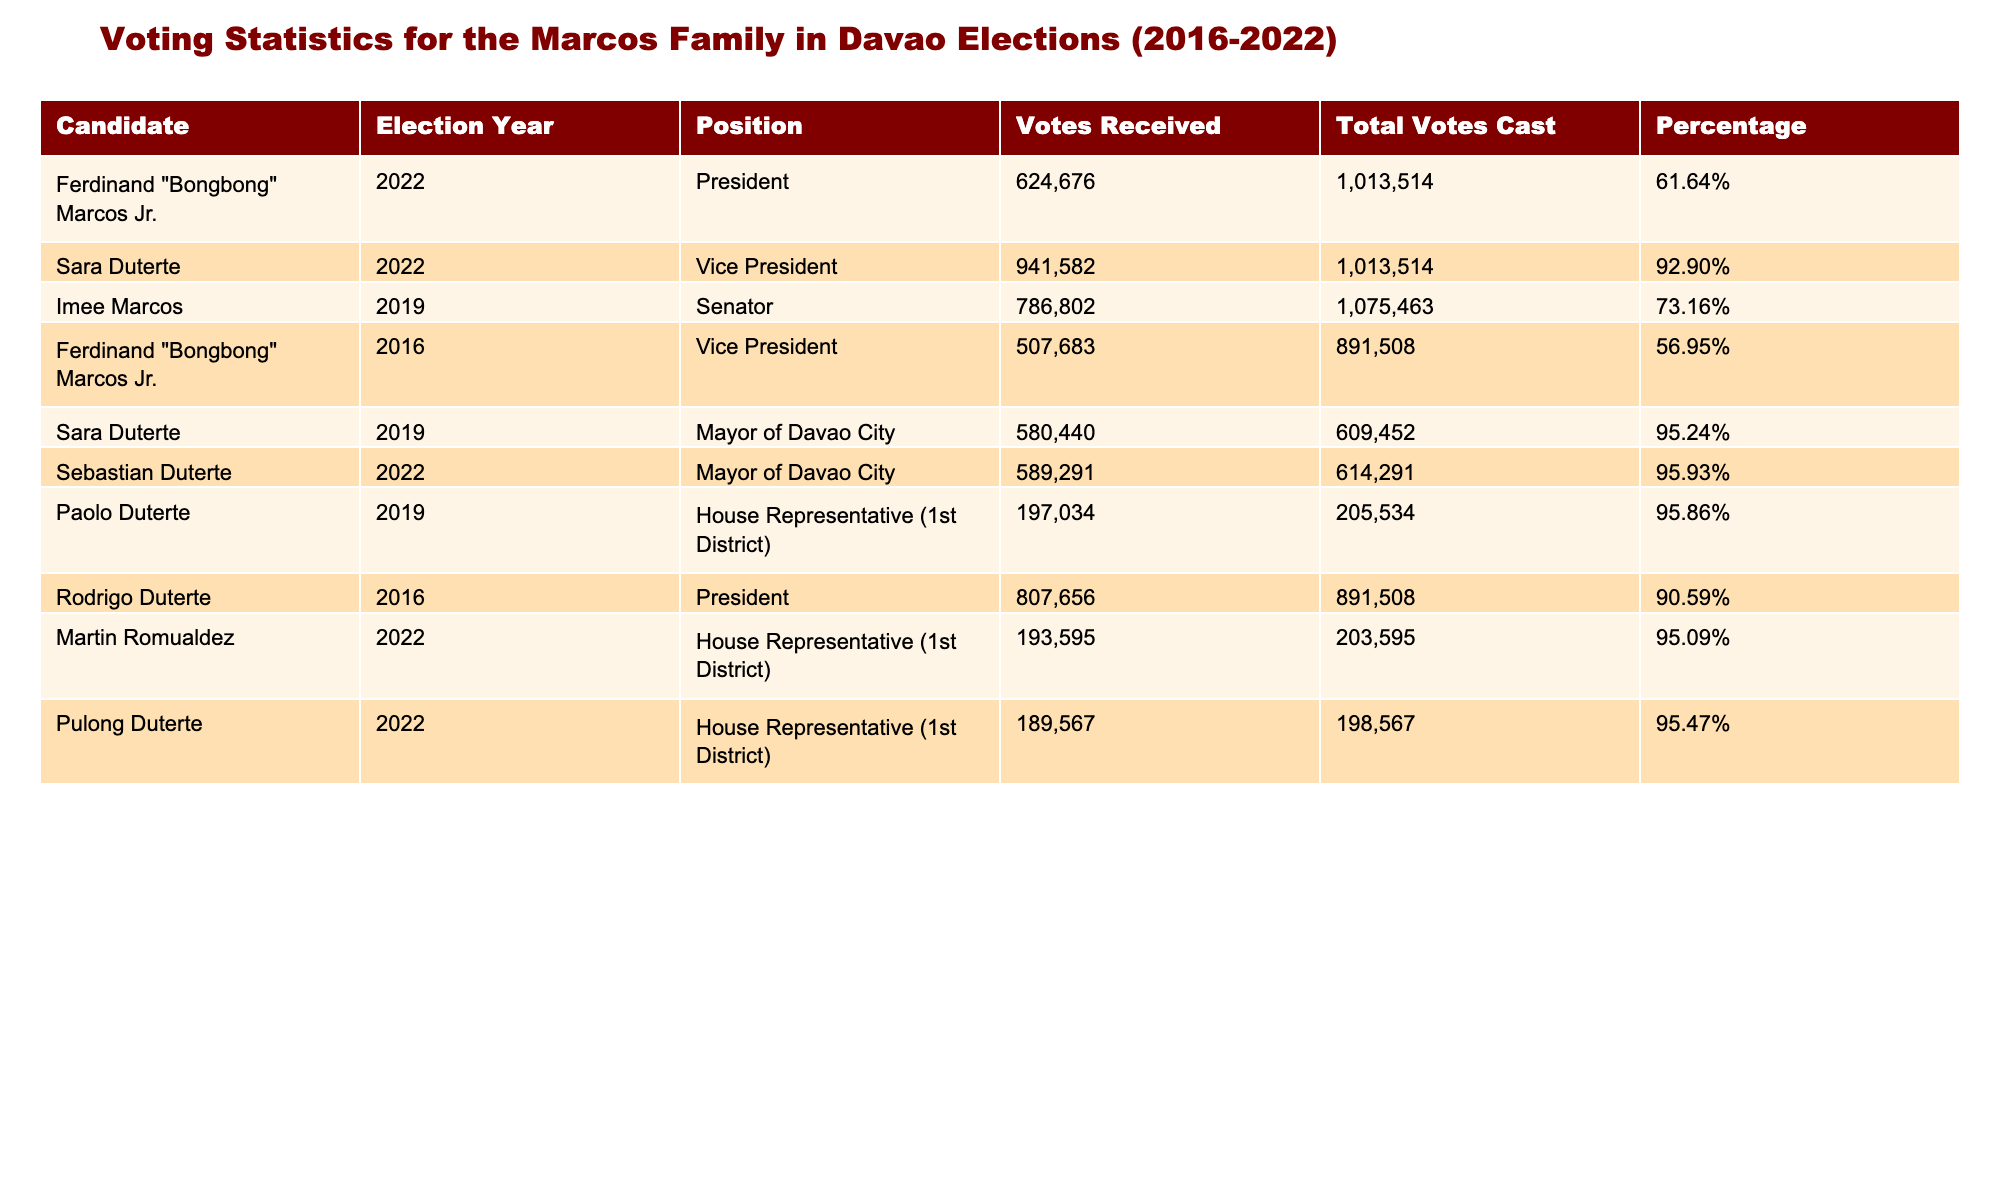What was the percentage of votes received by Ferdinand "Bongbong" Marcos Jr. in the 2022 presidential election? In the table, the percentage for Ferdinand "Bongbong" Marcos Jr. in the 2022 election is listed as 61.64%.
Answer: 61.64% Who received the most votes in the 2022 vice presidential election? The table shows that Sara Duterte received the most votes as Vice President in 2022 with 941,582 votes.
Answer: Sara Duterte What was the total number of votes cast in the 2019 senatorial election? According to the table, there were a total of 1,075,463 votes cast in the 2019 senatorial election.
Answer: 1,075,463 How much higher was the percentage of votes received by Sara Duterte in 2022 compared to Ferdinand "Bongbong" Marcos Jr. in 2016? Sara Duterte received 92.90% in 2022, while Ferdinand "Bongbong" Marcos Jr. received 56.95% in 2016. The difference is 92.90% - 56.95% = 35.95%.
Answer: 35.95% Did Imee Marcos receive more votes than Ferdinand "Bongbong" Marcos Jr. in the 2016 election? Imee Marcos received 786,802 votes in 2019 while Ferdinand "Bongbong" Marcos Jr. received 507,683 votes in 2016. Thus, Imee Marcos received more votes.
Answer: Yes What was the combined total of votes received by the Marcos family in the 2022 elections for President and Vice President? In 2022, Ferdinand "Bongbong" Marcos Jr. received 624,676 votes for President and Sara Duterte received 941,582 votes for Vice President. The total is 624,676 + 941,582 = 1,566,258 votes.
Answer: 1,566,258 Which candidate had the lowest percentage of votes in the elections listed? The table shows that Ferdinand "Bongbong" Marcos Jr. had the lowest percentage in the 2016 Vice Presidential election at 56.95%.
Answer: Ferdinand "Bongbong" Marcos Jr. (2016) What percentage of total votes cast did the winning candidates receive in the 2022 elections? In the 2022 elections, Sara Duterte received 92.90% and Ferdinand "Bongbong" Marcos Jr. received 61.64%. Both winning percentages do not require summation but emphasize that winning candidates received high percentages.
Answer: 92.90% and 61.64% respectively 